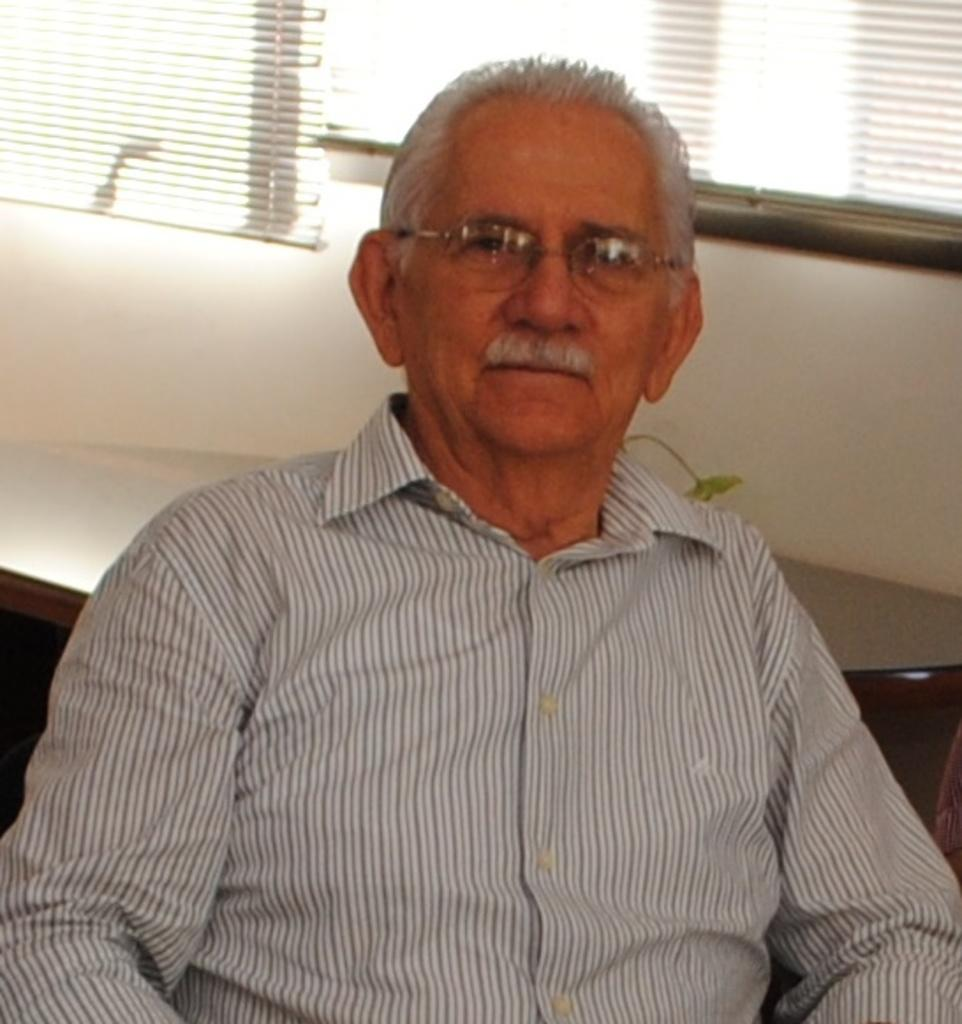What is the man in the image doing? The man is sitting in the image. What can be seen on the windows in the image? Window blinds are visible in the image. What type of structure is present in the image? There is a wall in the image. What type of net is being used by the man in the image? There is no net present in the image; the man is simply sitting. 